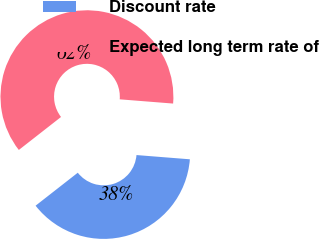<chart> <loc_0><loc_0><loc_500><loc_500><pie_chart><fcel>Discount rate<fcel>Expected long term rate of<nl><fcel>38.18%<fcel>61.82%<nl></chart> 